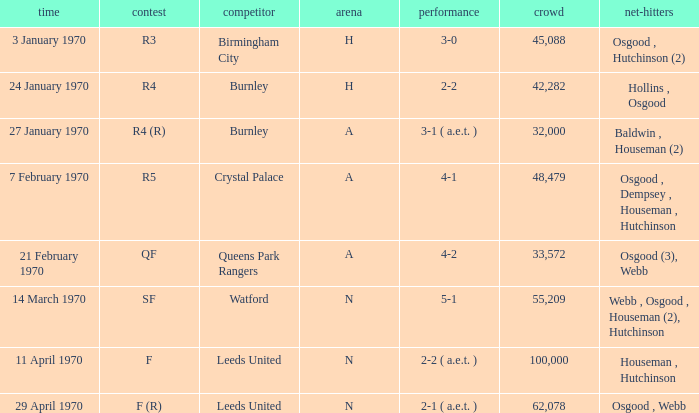What is the highest attendance at a game with a result of 5-1? 55209.0. 